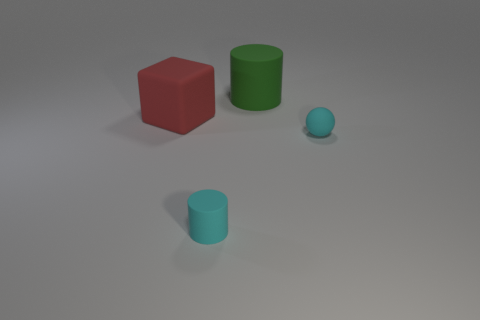Subtract all red cylinders. Subtract all red spheres. How many cylinders are left? 2 Add 3 tiny things. How many objects exist? 7 Subtract all cubes. How many objects are left? 3 Add 3 small cyan matte cylinders. How many small cyan matte cylinders exist? 4 Subtract 0 blue cylinders. How many objects are left? 4 Subtract all large yellow spheres. Subtract all red blocks. How many objects are left? 3 Add 3 things. How many things are left? 7 